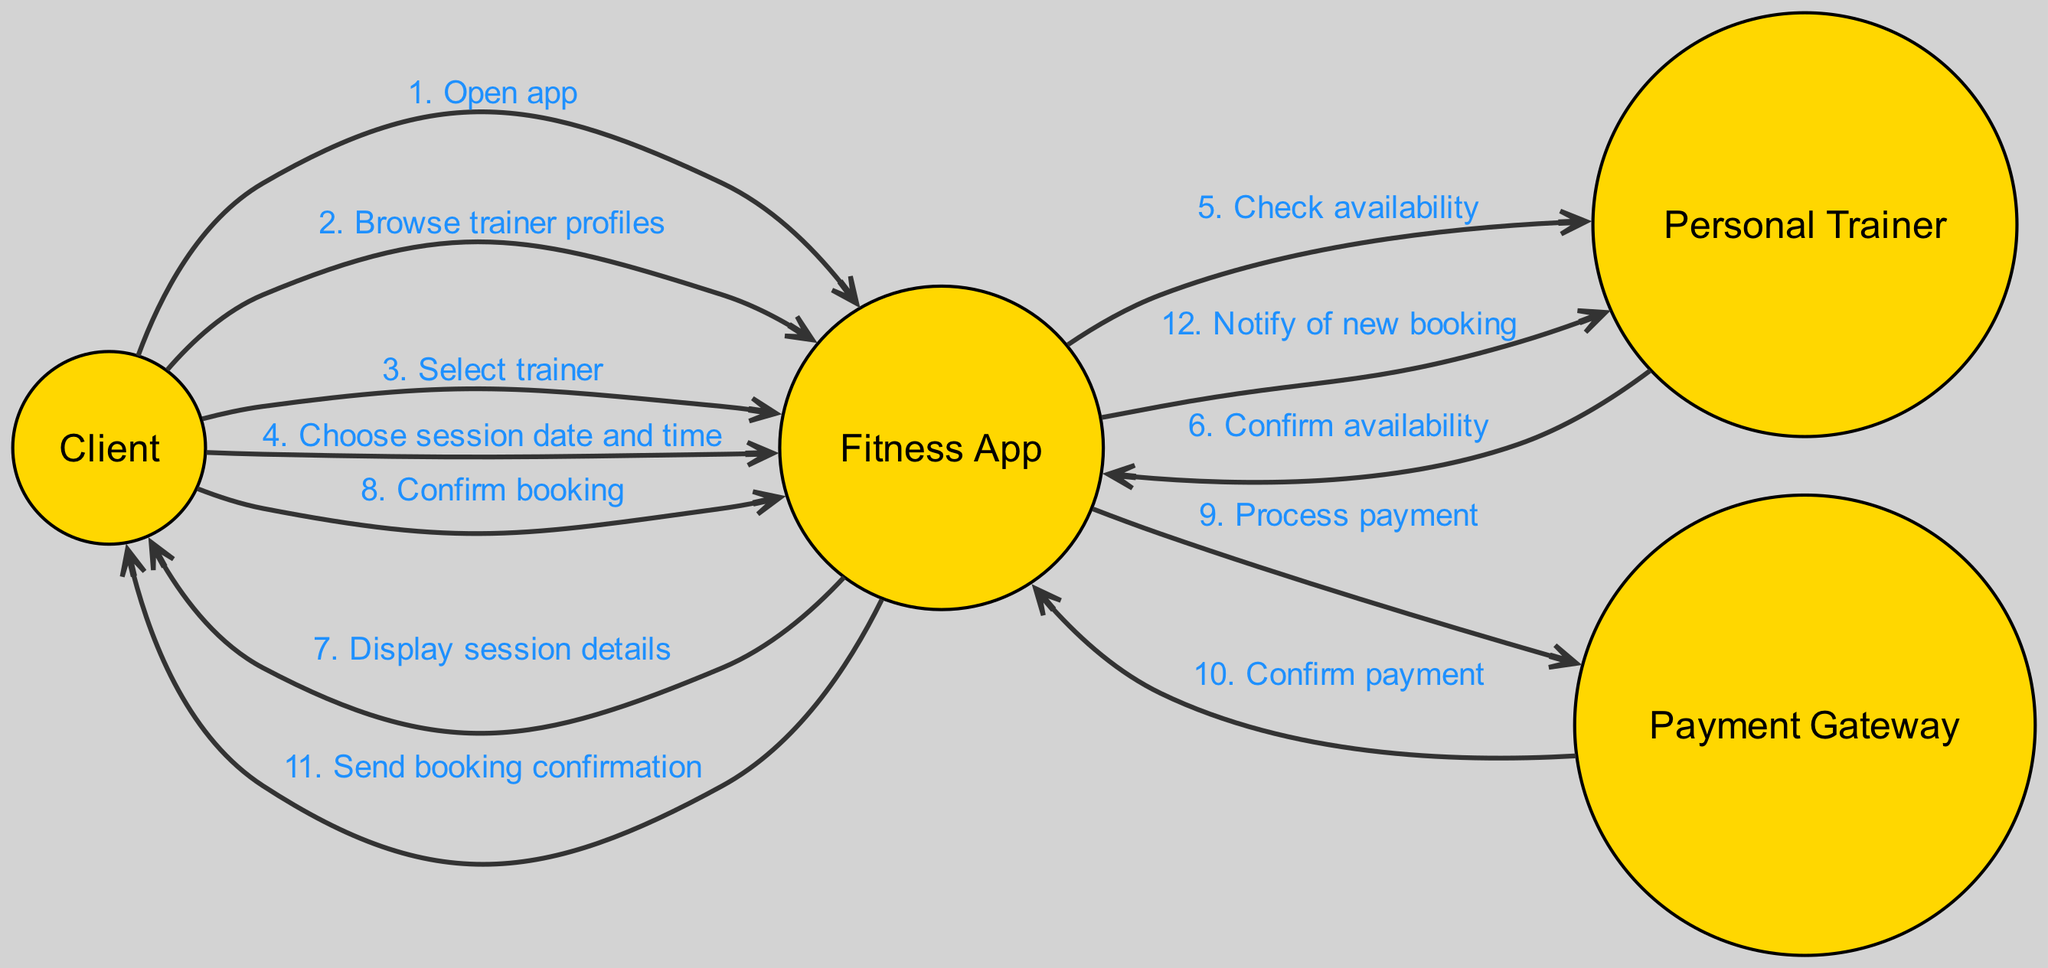What is the first action taken by the Client? The first interaction in the diagram shows that the Client opens the app, which is directly stated as the initial action.
Answer: Open app How many total actors are represented in the diagram? There are four distinct actors in the diagram: Client, Fitness App, Personal Trainer, and Payment Gateway, as counted from the list of actors.
Answer: Four What is the message sent from the Fitness App to the Personal Trainer? The interaction indicates that the Fitness App checks the Personal Trainer's availability, which is clearly stated in the message exchanged.
Answer: Check availability Which actor processes the payment? According to the diagram, the Payment Gateway is responsible for processing the payment, as indicated in the interaction where the Fitness App sends the message to it.
Answer: Payment Gateway What happens after the Client confirms the booking? After the Client confirms the booking, the Fitness App processes the payment, which follows directly in the interaction sequence.
Answer: Process payment What is the last notification sent in the sequence? The last interaction sends a notification to the Personal Trainer about the new booking, as shown in the final message exchange in the diagram.
Answer: Notify of new booking Which actor sends the booking confirmation to the Client? The Fitness App sends the booking confirmation to the Client after the payment is confirmed, as indicated in the sequential flow of the interactions.
Answer: Fitness App What is the total number of messages exchanged in the diagram? By counting each interaction listed in the diagram, there are twelve messages exchanged throughout the booking process, demonstrating the sequence of actions taken.
Answer: Twelve 